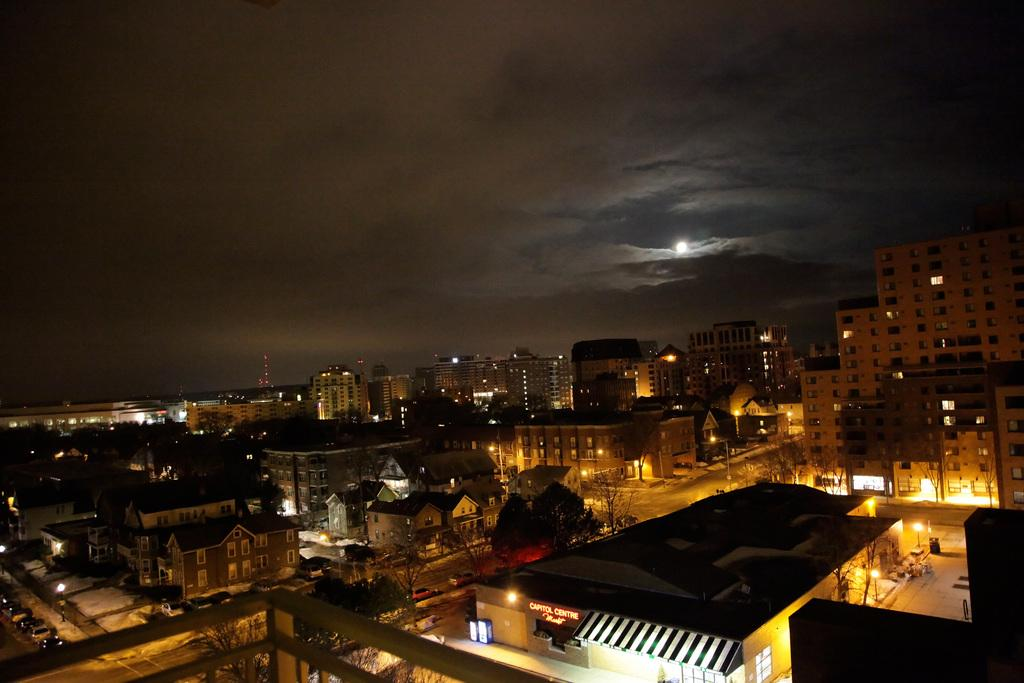What type of structures can be seen in the image? There are buildings in the image. What feature of the buildings is visible in the image? There are windows visible in the image. What can be seen illuminating the scene in the image? There are lights in the image. What type of vegetation is present in the image? There are trees in the image. What type of transportation is visible on the road in the image? There are vehicles on the road in the image. What part of the natural environment is visible in the image? The sky is visible in the image. What celestial body is visible in the image? The moon is visible in the image. What type of wool is being used to decorate the buildings in the image? There is no wool present in the image, and the buildings are not being decorated with any material. 